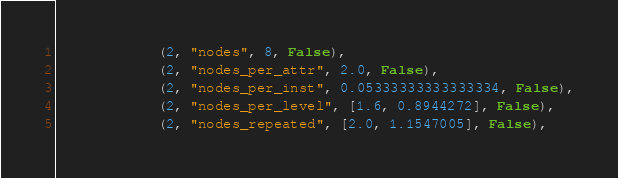<code> <loc_0><loc_0><loc_500><loc_500><_Python_>            (2, "nodes", 8, False),
            (2, "nodes_per_attr", 2.0, False),
            (2, "nodes_per_inst", 0.05333333333333334, False),
            (2, "nodes_per_level", [1.6, 0.8944272], False),
            (2, "nodes_repeated", [2.0, 1.1547005], False),</code> 